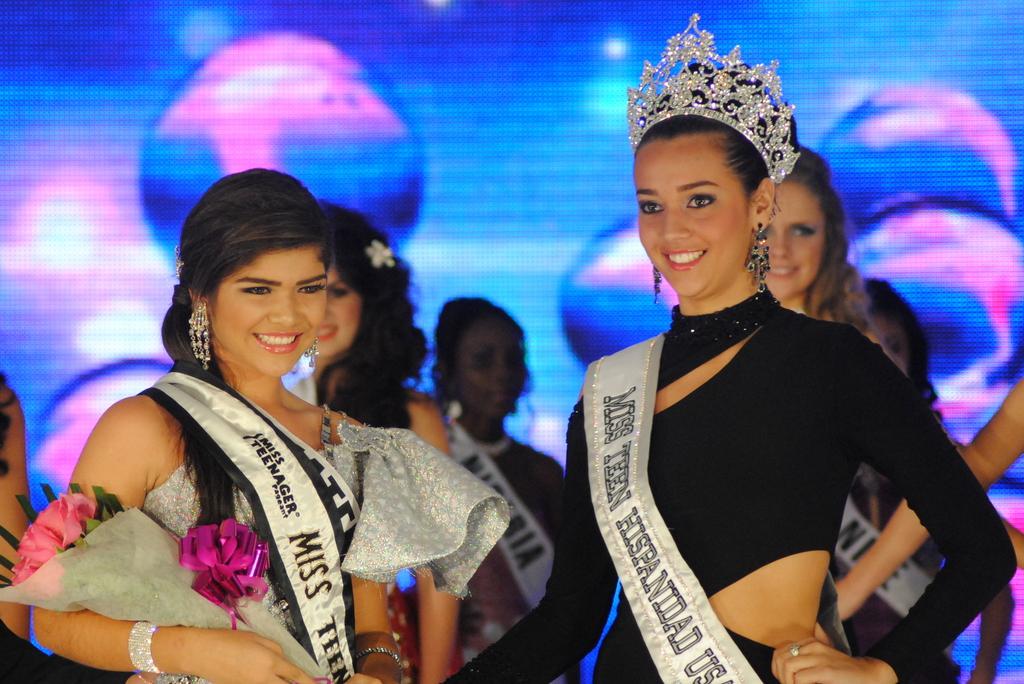What color is the text on the left girl?
Give a very brief answer. Black. 